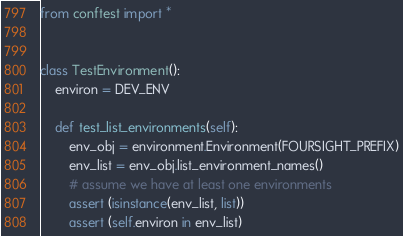<code> <loc_0><loc_0><loc_500><loc_500><_Python_>from conftest import *


class TestEnvironment():
    environ = DEV_ENV

    def test_list_environments(self):
        env_obj = environment.Environment(FOURSIGHT_PREFIX)
        env_list = env_obj.list_environment_names()
        # assume we have at least one environments
        assert (isinstance(env_list, list))
        assert (self.environ in env_list)

</code> 